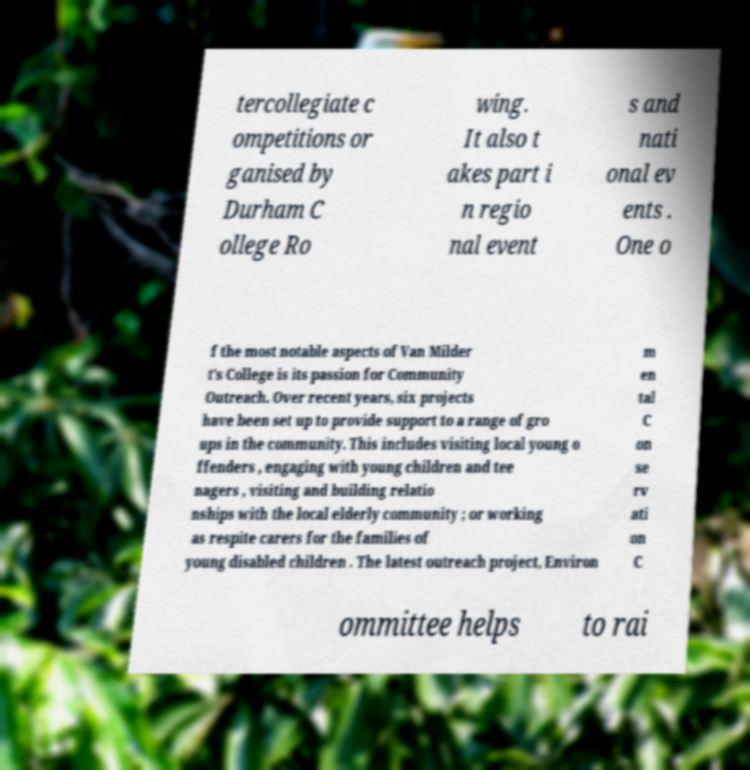What messages or text are displayed in this image? I need them in a readable, typed format. tercollegiate c ompetitions or ganised by Durham C ollege Ro wing. It also t akes part i n regio nal event s and nati onal ev ents . One o f the most notable aspects of Van Milder t's College is its passion for Community Outreach. Over recent years, six projects have been set up to provide support to a range of gro ups in the community. This includes visiting local young o ffenders , engaging with young children and tee nagers , visiting and building relatio nships with the local elderly community ; or working as respite carers for the families of young disabled children . The latest outreach project, Environ m en tal C on se rv ati on C ommittee helps to rai 